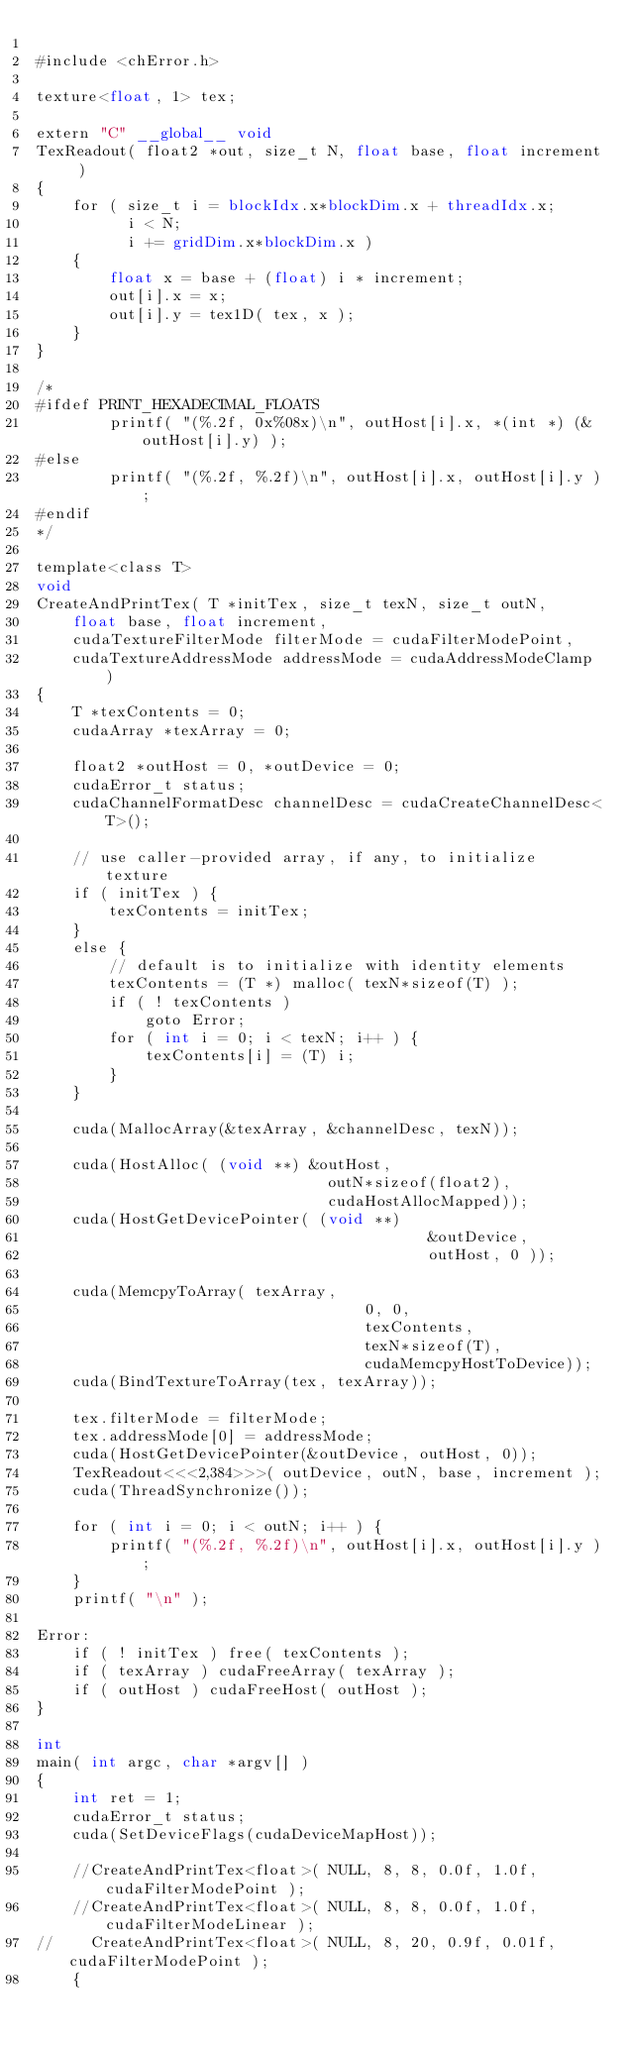<code> <loc_0><loc_0><loc_500><loc_500><_Cuda_>
#include <chError.h>

texture<float, 1> tex;

extern "C" __global__ void
TexReadout( float2 *out, size_t N, float base, float increment )
{
    for ( size_t i = blockIdx.x*blockDim.x + threadIdx.x; 
          i < N; 
          i += gridDim.x*blockDim.x )
    {
        float x = base + (float) i * increment;
        out[i].x = x;
        out[i].y = tex1D( tex, x );
    }
}

/*
#ifdef PRINT_HEXADECIMAL_FLOATS
        printf( "(%.2f, 0x%08x)\n", outHost[i].x, *(int *) (&outHost[i].y) );
#else
        printf( "(%.2f, %.2f)\n", outHost[i].x, outHost[i].y );
#endif
*/

template<class T>
void
CreateAndPrintTex( T *initTex, size_t texN, size_t outN, 
    float base, float increment, 
    cudaTextureFilterMode filterMode = cudaFilterModePoint, 
    cudaTextureAddressMode addressMode = cudaAddressModeClamp )
{
    T *texContents = 0;
    cudaArray *texArray = 0;

    float2 *outHost = 0, *outDevice = 0;
    cudaError_t status;
    cudaChannelFormatDesc channelDesc = cudaCreateChannelDesc<T>();

    // use caller-provided array, if any, to initialize texture
    if ( initTex ) {
        texContents = initTex;
    }
    else {
        // default is to initialize with identity elements
        texContents = (T *) malloc( texN*sizeof(T) );
        if ( ! texContents )
            goto Error;
        for ( int i = 0; i < texN; i++ ) {
            texContents[i] = (T) i;
        }
    }

    cuda(MallocArray(&texArray, &channelDesc, texN));

    cuda(HostAlloc( (void **) &outHost, 
                                outN*sizeof(float2), 
                                cudaHostAllocMapped));
    cuda(HostGetDevicePointer( (void **) 
                                           &outDevice, 
                                           outHost, 0 ));

    cuda(MemcpyToArray( texArray, 
                                    0, 0, 
                                    texContents, 
                                    texN*sizeof(T), 
                                    cudaMemcpyHostToDevice));
    cuda(BindTextureToArray(tex, texArray));

    tex.filterMode = filterMode;
    tex.addressMode[0] = addressMode;
    cuda(HostGetDevicePointer(&outDevice, outHost, 0));
    TexReadout<<<2,384>>>( outDevice, outN, base, increment );
    cuda(ThreadSynchronize());

    for ( int i = 0; i < outN; i++ ) {
        printf( "(%.2f, %.2f)\n", outHost[i].x, outHost[i].y );
    }
    printf( "\n" );

Error:
    if ( ! initTex ) free( texContents );
    if ( texArray ) cudaFreeArray( texArray );
    if ( outHost ) cudaFreeHost( outHost );
}

int
main( int argc, char *argv[] )
{
    int ret = 1;
    cudaError_t status;
    cuda(SetDeviceFlags(cudaDeviceMapHost));

    //CreateAndPrintTex<float>( NULL, 8, 8, 0.0f, 1.0f, cudaFilterModePoint );
    //CreateAndPrintTex<float>( NULL, 8, 8, 0.0f, 1.0f, cudaFilterModeLinear );
//    CreateAndPrintTex<float>( NULL, 8, 20, 0.9f, 0.01f, cudaFilterModePoint );
    {</code> 